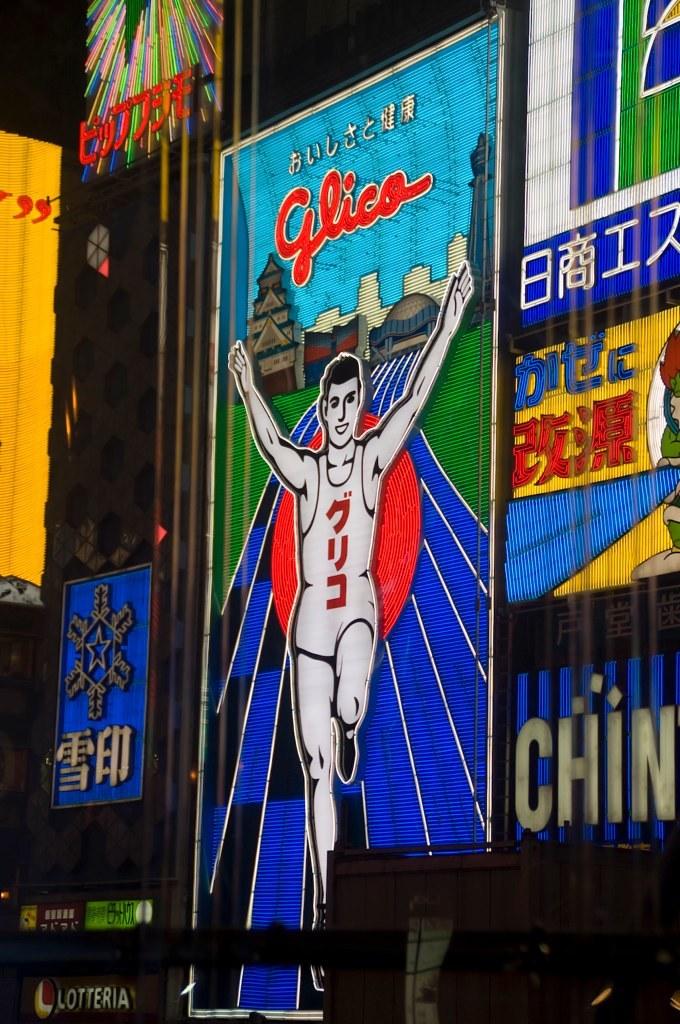The english word is chin?
Your answer should be very brief. Yes. What is the english word shown?
Give a very brief answer. Glico. 